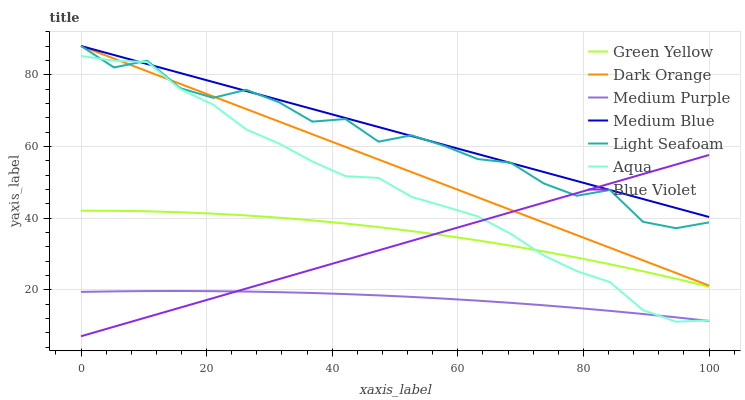Does Medium Purple have the minimum area under the curve?
Answer yes or no. Yes. Does Medium Blue have the maximum area under the curve?
Answer yes or no. Yes. Does Light Seafoam have the minimum area under the curve?
Answer yes or no. No. Does Light Seafoam have the maximum area under the curve?
Answer yes or no. No. Is Blue Violet the smoothest?
Answer yes or no. Yes. Is Light Seafoam the roughest?
Answer yes or no. Yes. Is Medium Blue the smoothest?
Answer yes or no. No. Is Medium Blue the roughest?
Answer yes or no. No. Does Blue Violet have the lowest value?
Answer yes or no. Yes. Does Light Seafoam have the lowest value?
Answer yes or no. No. Does Medium Blue have the highest value?
Answer yes or no. Yes. Does Aqua have the highest value?
Answer yes or no. No. Is Green Yellow less than Dark Orange?
Answer yes or no. Yes. Is Green Yellow greater than Medium Purple?
Answer yes or no. Yes. Does Aqua intersect Dark Orange?
Answer yes or no. Yes. Is Aqua less than Dark Orange?
Answer yes or no. No. Is Aqua greater than Dark Orange?
Answer yes or no. No. Does Green Yellow intersect Dark Orange?
Answer yes or no. No. 